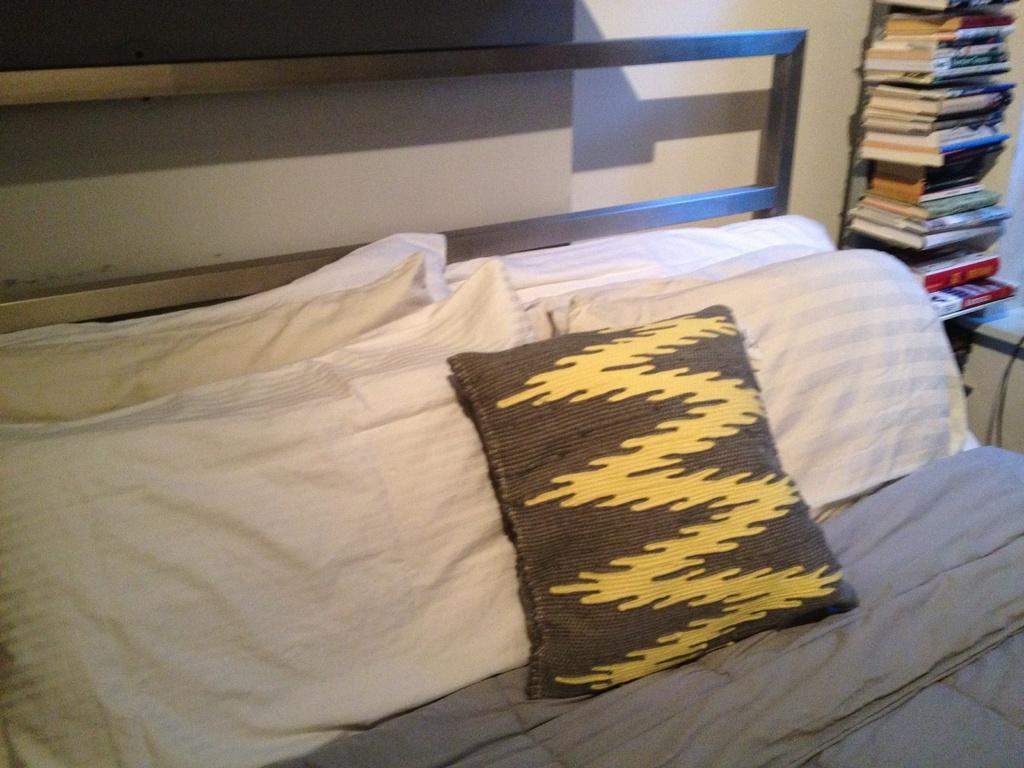What type of furniture is in the image? There is a bed in the image. What accessories are on the bed? The bed has pillows and a blanket. What can be seen on the wall in the image? There is a bookshelf with books visible on the wall in the image. What is the purpose of the bookshelf? The bookshelf is used for storing books. How does the beggar interact with the scene in the image? There is no beggar present in the image. What type of selection is available on the bookshelf in the image? The image does not provide information about the specific books on the bookshelf, so it is impossible to determine the selection available. 